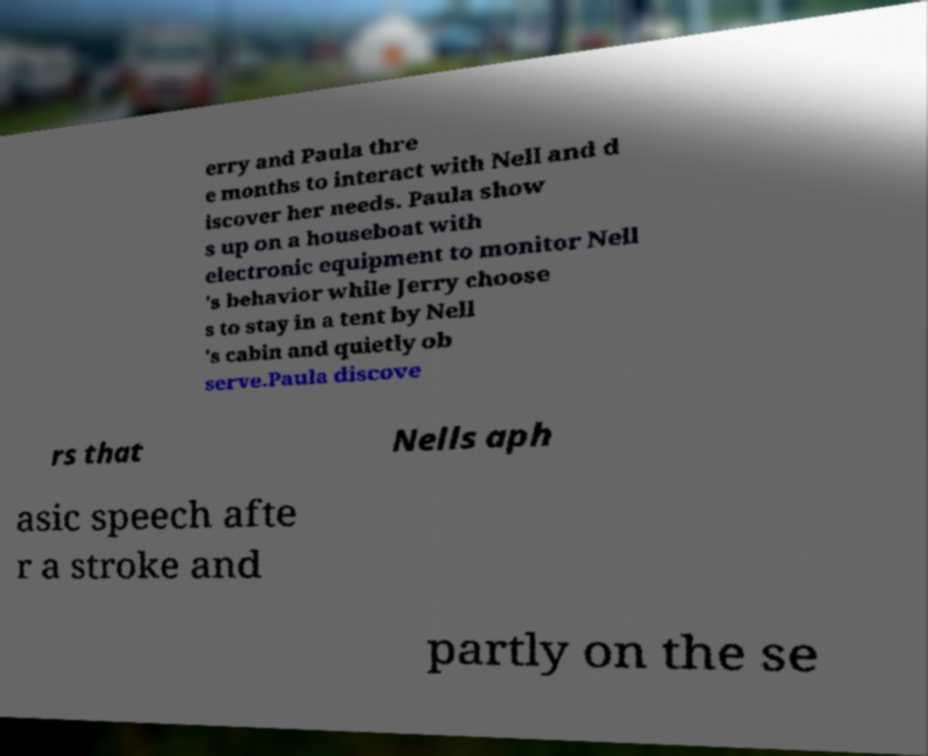Please identify and transcribe the text found in this image. erry and Paula thre e months to interact with Nell and d iscover her needs. Paula show s up on a houseboat with electronic equipment to monitor Nell 's behavior while Jerry choose s to stay in a tent by Nell 's cabin and quietly ob serve.Paula discove rs that Nells aph asic speech afte r a stroke and partly on the se 